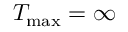Convert formula to latex. <formula><loc_0><loc_0><loc_500><loc_500>T _ { \max } = \infty</formula> 